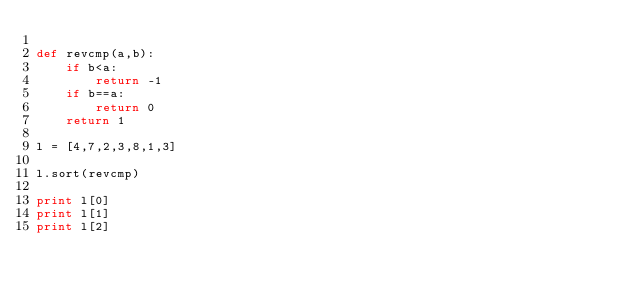Convert code to text. <code><loc_0><loc_0><loc_500><loc_500><_Python_>
def revcmp(a,b):
    if b<a:
        return -1
    if b==a:
        return 0
    return 1

l = [4,7,2,3,8,1,3]

l.sort(revcmp)

print l[0]
print l[1]
print l[2]
</code> 